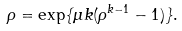<formula> <loc_0><loc_0><loc_500><loc_500>\rho = \exp \{ \mu k ( \rho ^ { k - 1 } - 1 ) \} .</formula> 